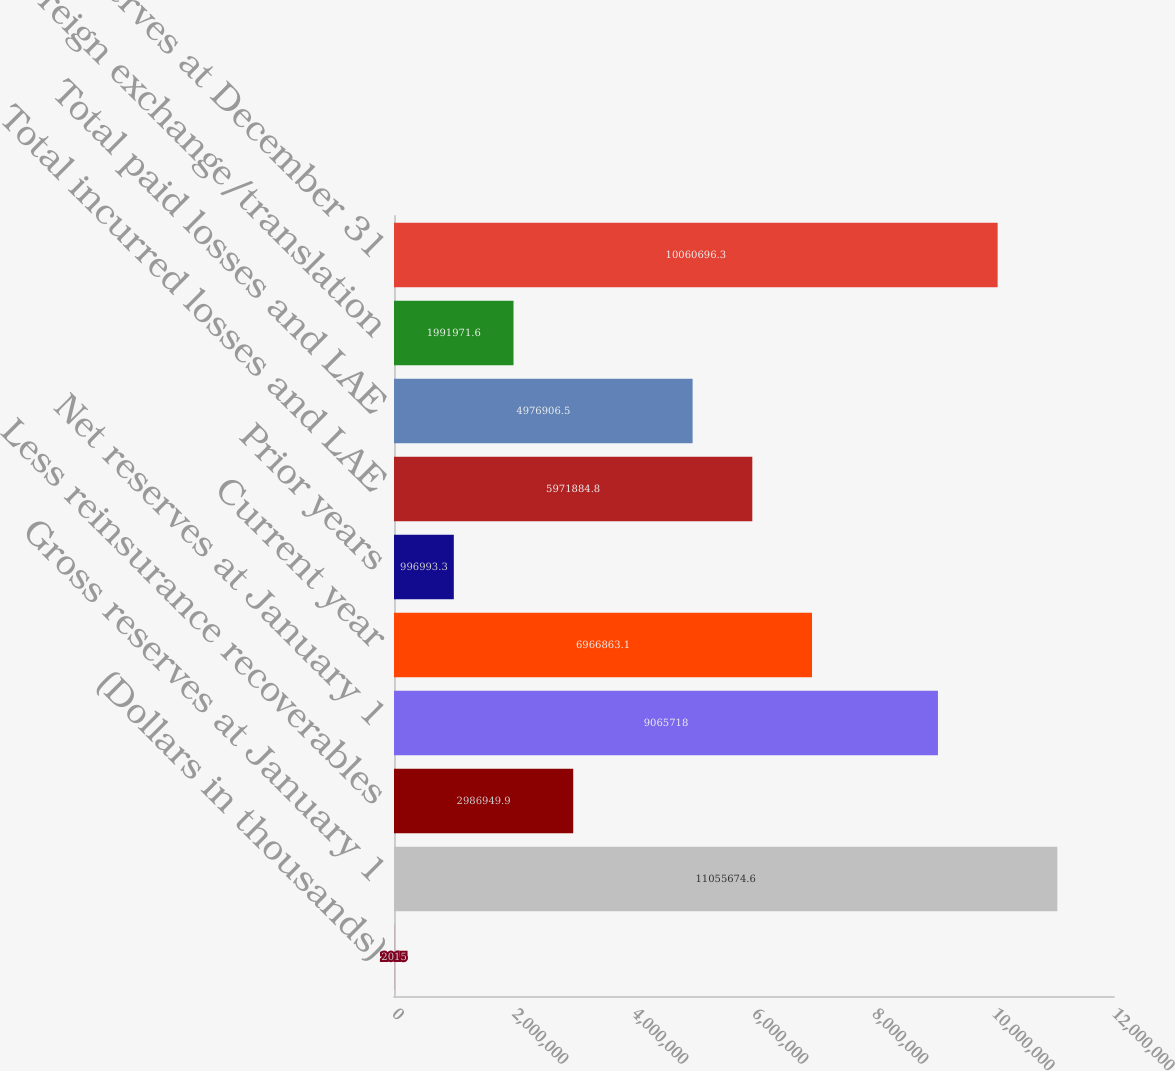Convert chart to OTSL. <chart><loc_0><loc_0><loc_500><loc_500><bar_chart><fcel>(Dollars in thousands)<fcel>Gross reserves at January 1<fcel>Less reinsurance recoverables<fcel>Net reserves at January 1<fcel>Current year<fcel>Prior years<fcel>Total incurred losses and LAE<fcel>Total paid losses and LAE<fcel>Foreign exchange/translation<fcel>Net reserves at December 31<nl><fcel>2015<fcel>1.10557e+07<fcel>2.98695e+06<fcel>9.06572e+06<fcel>6.96686e+06<fcel>996993<fcel>5.97188e+06<fcel>4.97691e+06<fcel>1.99197e+06<fcel>1.00607e+07<nl></chart> 